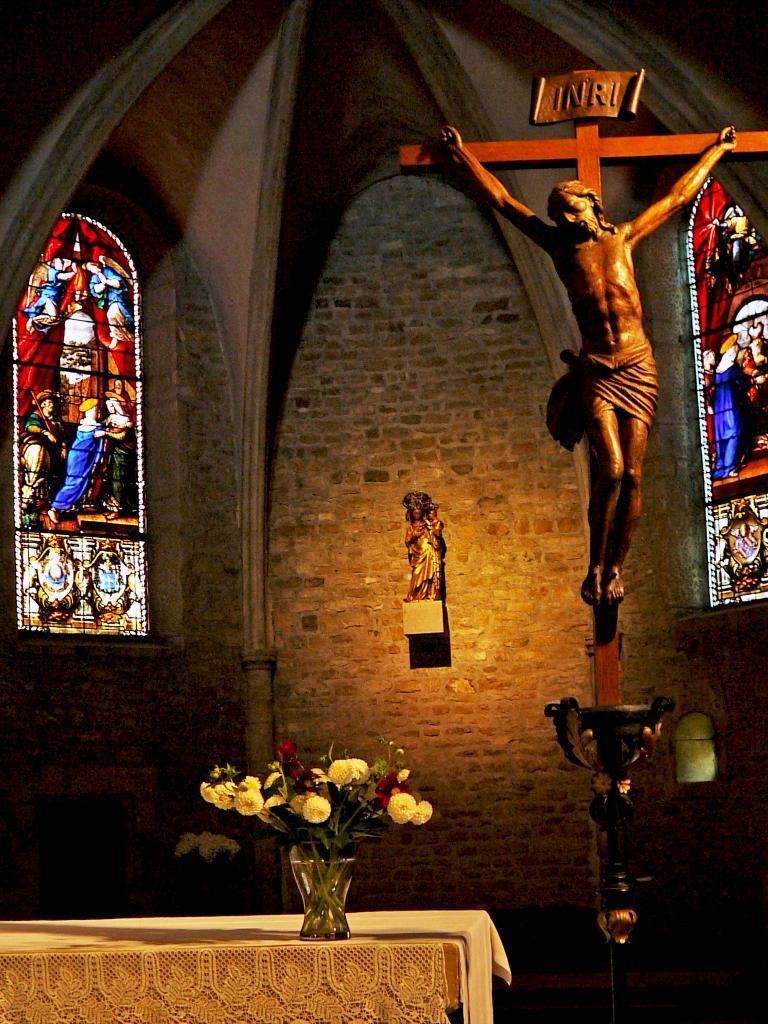Describe this image in one or two sentences. In this image we can see inside of a church. There are few idols in the image. There are few flowers in the vase. There is a table in the image. There is an object in the image. We can see the painting on the glasses. 